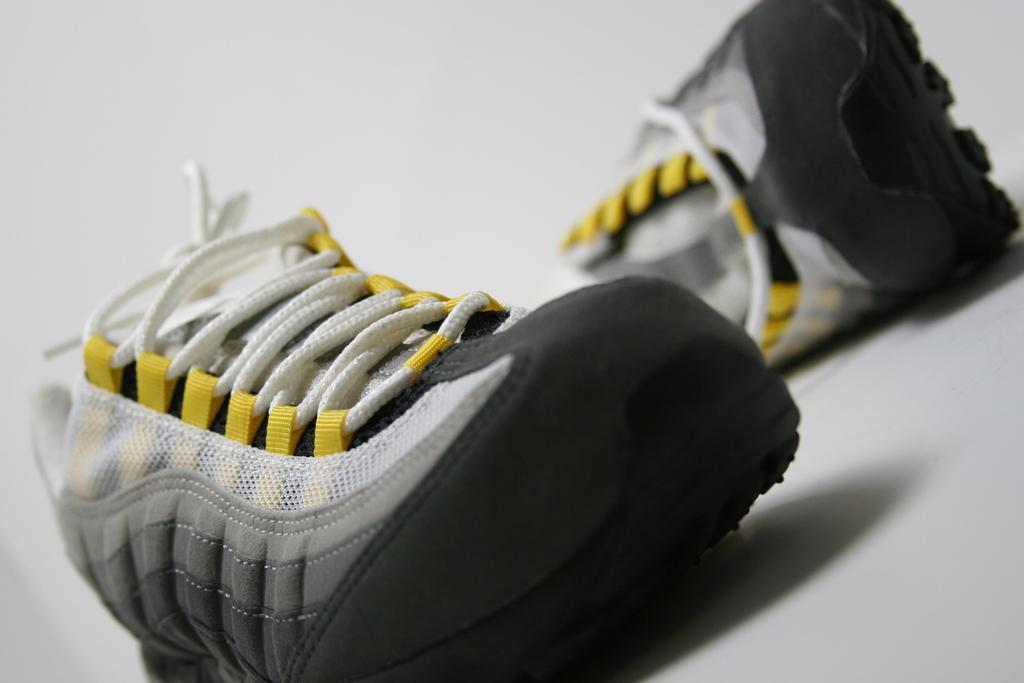What type of footwear is visible in the image? There is a pair of shoes in the image. Where are the shoes located in the image? The shoes are on an object. What type of prose is being read by the shoes in the image? There is no prose or reading activity present in the image, as the subject is a pair of shoes. How does the comb fit into the image? There is no comb present in the image, so it cannot fit into the image. 